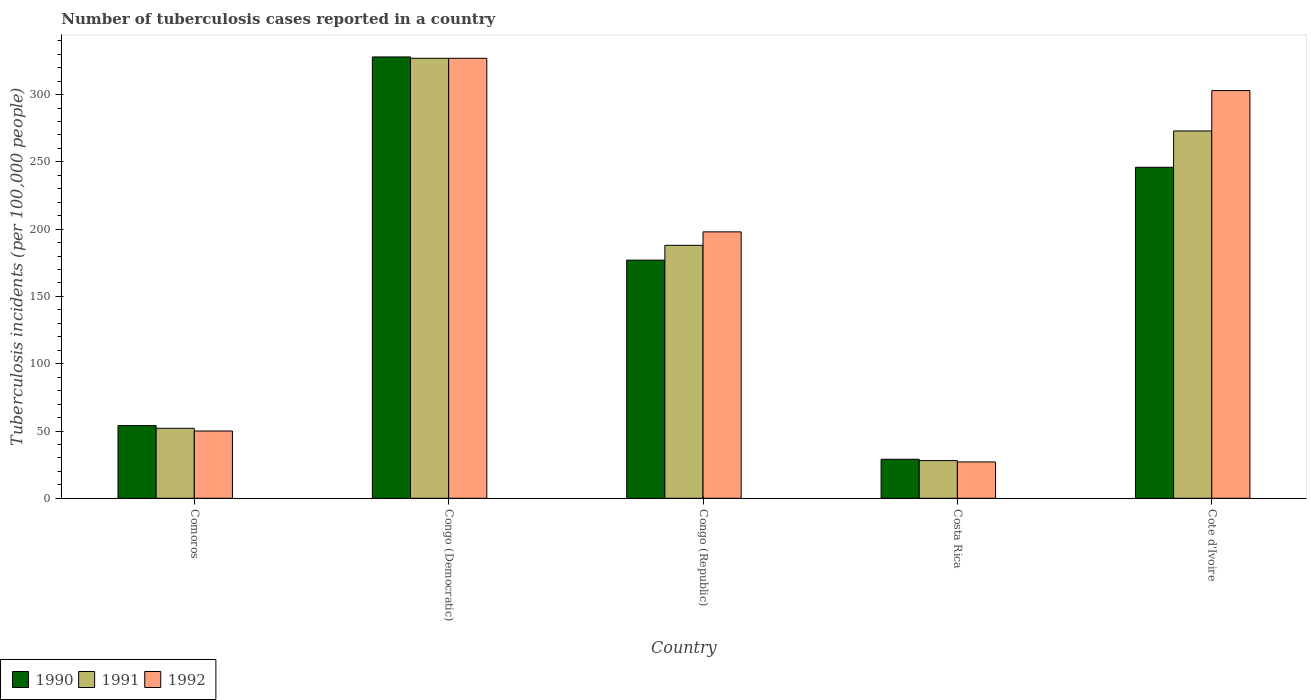In how many cases, is the number of bars for a given country not equal to the number of legend labels?
Make the answer very short. 0. Across all countries, what is the maximum number of tuberculosis cases reported in in 1992?
Offer a terse response. 327. In which country was the number of tuberculosis cases reported in in 1991 maximum?
Offer a terse response. Congo (Democratic). What is the total number of tuberculosis cases reported in in 1992 in the graph?
Provide a succinct answer. 905. What is the difference between the number of tuberculosis cases reported in in 1990 in Comoros and that in Cote d'Ivoire?
Make the answer very short. -192. What is the difference between the number of tuberculosis cases reported in in 1991 in Congo (Democratic) and the number of tuberculosis cases reported in in 1992 in Costa Rica?
Offer a very short reply. 300. What is the average number of tuberculosis cases reported in in 1991 per country?
Offer a terse response. 173.6. What is the difference between the number of tuberculosis cases reported in of/in 1990 and number of tuberculosis cases reported in of/in 1991 in Congo (Democratic)?
Your response must be concise. 1. What is the ratio of the number of tuberculosis cases reported in in 1990 in Congo (Republic) to that in Costa Rica?
Ensure brevity in your answer.  6.1. Is the number of tuberculosis cases reported in in 1990 in Congo (Democratic) less than that in Costa Rica?
Offer a terse response. No. What is the difference between the highest and the second highest number of tuberculosis cases reported in in 1990?
Make the answer very short. 151. What is the difference between the highest and the lowest number of tuberculosis cases reported in in 1990?
Keep it short and to the point. 299. In how many countries, is the number of tuberculosis cases reported in in 1991 greater than the average number of tuberculosis cases reported in in 1991 taken over all countries?
Your answer should be very brief. 3. What does the 2nd bar from the right in Cote d'Ivoire represents?
Provide a short and direct response. 1991. How many bars are there?
Give a very brief answer. 15. Are all the bars in the graph horizontal?
Ensure brevity in your answer.  No. How many countries are there in the graph?
Offer a very short reply. 5. Are the values on the major ticks of Y-axis written in scientific E-notation?
Your answer should be very brief. No. Does the graph contain grids?
Offer a very short reply. No. Where does the legend appear in the graph?
Ensure brevity in your answer.  Bottom left. How are the legend labels stacked?
Offer a very short reply. Horizontal. What is the title of the graph?
Your answer should be very brief. Number of tuberculosis cases reported in a country. Does "2011" appear as one of the legend labels in the graph?
Ensure brevity in your answer.  No. What is the label or title of the X-axis?
Make the answer very short. Country. What is the label or title of the Y-axis?
Your answer should be very brief. Tuberculosis incidents (per 100,0 people). What is the Tuberculosis incidents (per 100,000 people) in 1990 in Comoros?
Provide a short and direct response. 54. What is the Tuberculosis incidents (per 100,000 people) of 1990 in Congo (Democratic)?
Your response must be concise. 328. What is the Tuberculosis incidents (per 100,000 people) in 1991 in Congo (Democratic)?
Keep it short and to the point. 327. What is the Tuberculosis incidents (per 100,000 people) in 1992 in Congo (Democratic)?
Provide a succinct answer. 327. What is the Tuberculosis incidents (per 100,000 people) of 1990 in Congo (Republic)?
Offer a terse response. 177. What is the Tuberculosis incidents (per 100,000 people) in 1991 in Congo (Republic)?
Your answer should be very brief. 188. What is the Tuberculosis incidents (per 100,000 people) of 1992 in Congo (Republic)?
Ensure brevity in your answer.  198. What is the Tuberculosis incidents (per 100,000 people) of 1991 in Costa Rica?
Ensure brevity in your answer.  28. What is the Tuberculosis incidents (per 100,000 people) of 1990 in Cote d'Ivoire?
Your response must be concise. 246. What is the Tuberculosis incidents (per 100,000 people) in 1991 in Cote d'Ivoire?
Keep it short and to the point. 273. What is the Tuberculosis incidents (per 100,000 people) in 1992 in Cote d'Ivoire?
Give a very brief answer. 303. Across all countries, what is the maximum Tuberculosis incidents (per 100,000 people) of 1990?
Ensure brevity in your answer.  328. Across all countries, what is the maximum Tuberculosis incidents (per 100,000 people) in 1991?
Provide a short and direct response. 327. Across all countries, what is the maximum Tuberculosis incidents (per 100,000 people) in 1992?
Your answer should be very brief. 327. Across all countries, what is the minimum Tuberculosis incidents (per 100,000 people) in 1990?
Ensure brevity in your answer.  29. What is the total Tuberculosis incidents (per 100,000 people) of 1990 in the graph?
Provide a succinct answer. 834. What is the total Tuberculosis incidents (per 100,000 people) of 1991 in the graph?
Your answer should be very brief. 868. What is the total Tuberculosis incidents (per 100,000 people) in 1992 in the graph?
Your answer should be compact. 905. What is the difference between the Tuberculosis incidents (per 100,000 people) in 1990 in Comoros and that in Congo (Democratic)?
Your answer should be compact. -274. What is the difference between the Tuberculosis incidents (per 100,000 people) of 1991 in Comoros and that in Congo (Democratic)?
Offer a terse response. -275. What is the difference between the Tuberculosis incidents (per 100,000 people) of 1992 in Comoros and that in Congo (Democratic)?
Your response must be concise. -277. What is the difference between the Tuberculosis incidents (per 100,000 people) of 1990 in Comoros and that in Congo (Republic)?
Give a very brief answer. -123. What is the difference between the Tuberculosis incidents (per 100,000 people) of 1991 in Comoros and that in Congo (Republic)?
Your answer should be very brief. -136. What is the difference between the Tuberculosis incidents (per 100,000 people) of 1992 in Comoros and that in Congo (Republic)?
Provide a short and direct response. -148. What is the difference between the Tuberculosis incidents (per 100,000 people) in 1991 in Comoros and that in Costa Rica?
Give a very brief answer. 24. What is the difference between the Tuberculosis incidents (per 100,000 people) in 1990 in Comoros and that in Cote d'Ivoire?
Provide a short and direct response. -192. What is the difference between the Tuberculosis incidents (per 100,000 people) in 1991 in Comoros and that in Cote d'Ivoire?
Your answer should be compact. -221. What is the difference between the Tuberculosis incidents (per 100,000 people) in 1992 in Comoros and that in Cote d'Ivoire?
Your answer should be very brief. -253. What is the difference between the Tuberculosis incidents (per 100,000 people) in 1990 in Congo (Democratic) and that in Congo (Republic)?
Ensure brevity in your answer.  151. What is the difference between the Tuberculosis incidents (per 100,000 people) of 1991 in Congo (Democratic) and that in Congo (Republic)?
Your answer should be very brief. 139. What is the difference between the Tuberculosis incidents (per 100,000 people) in 1992 in Congo (Democratic) and that in Congo (Republic)?
Ensure brevity in your answer.  129. What is the difference between the Tuberculosis incidents (per 100,000 people) in 1990 in Congo (Democratic) and that in Costa Rica?
Give a very brief answer. 299. What is the difference between the Tuberculosis incidents (per 100,000 people) in 1991 in Congo (Democratic) and that in Costa Rica?
Offer a very short reply. 299. What is the difference between the Tuberculosis incidents (per 100,000 people) of 1992 in Congo (Democratic) and that in Costa Rica?
Make the answer very short. 300. What is the difference between the Tuberculosis incidents (per 100,000 people) of 1990 in Congo (Republic) and that in Costa Rica?
Provide a short and direct response. 148. What is the difference between the Tuberculosis incidents (per 100,000 people) of 1991 in Congo (Republic) and that in Costa Rica?
Provide a succinct answer. 160. What is the difference between the Tuberculosis incidents (per 100,000 people) in 1992 in Congo (Republic) and that in Costa Rica?
Give a very brief answer. 171. What is the difference between the Tuberculosis incidents (per 100,000 people) of 1990 in Congo (Republic) and that in Cote d'Ivoire?
Your response must be concise. -69. What is the difference between the Tuberculosis incidents (per 100,000 people) in 1991 in Congo (Republic) and that in Cote d'Ivoire?
Provide a short and direct response. -85. What is the difference between the Tuberculosis incidents (per 100,000 people) in 1992 in Congo (Republic) and that in Cote d'Ivoire?
Make the answer very short. -105. What is the difference between the Tuberculosis incidents (per 100,000 people) in 1990 in Costa Rica and that in Cote d'Ivoire?
Your answer should be very brief. -217. What is the difference between the Tuberculosis incidents (per 100,000 people) in 1991 in Costa Rica and that in Cote d'Ivoire?
Make the answer very short. -245. What is the difference between the Tuberculosis incidents (per 100,000 people) of 1992 in Costa Rica and that in Cote d'Ivoire?
Your answer should be compact. -276. What is the difference between the Tuberculosis incidents (per 100,000 people) in 1990 in Comoros and the Tuberculosis incidents (per 100,000 people) in 1991 in Congo (Democratic)?
Ensure brevity in your answer.  -273. What is the difference between the Tuberculosis incidents (per 100,000 people) in 1990 in Comoros and the Tuberculosis incidents (per 100,000 people) in 1992 in Congo (Democratic)?
Keep it short and to the point. -273. What is the difference between the Tuberculosis incidents (per 100,000 people) of 1991 in Comoros and the Tuberculosis incidents (per 100,000 people) of 1992 in Congo (Democratic)?
Your response must be concise. -275. What is the difference between the Tuberculosis incidents (per 100,000 people) in 1990 in Comoros and the Tuberculosis incidents (per 100,000 people) in 1991 in Congo (Republic)?
Keep it short and to the point. -134. What is the difference between the Tuberculosis incidents (per 100,000 people) of 1990 in Comoros and the Tuberculosis incidents (per 100,000 people) of 1992 in Congo (Republic)?
Your response must be concise. -144. What is the difference between the Tuberculosis incidents (per 100,000 people) of 1991 in Comoros and the Tuberculosis incidents (per 100,000 people) of 1992 in Congo (Republic)?
Provide a short and direct response. -146. What is the difference between the Tuberculosis incidents (per 100,000 people) of 1990 in Comoros and the Tuberculosis incidents (per 100,000 people) of 1991 in Cote d'Ivoire?
Your answer should be very brief. -219. What is the difference between the Tuberculosis incidents (per 100,000 people) in 1990 in Comoros and the Tuberculosis incidents (per 100,000 people) in 1992 in Cote d'Ivoire?
Provide a succinct answer. -249. What is the difference between the Tuberculosis incidents (per 100,000 people) in 1991 in Comoros and the Tuberculosis incidents (per 100,000 people) in 1992 in Cote d'Ivoire?
Make the answer very short. -251. What is the difference between the Tuberculosis incidents (per 100,000 people) in 1990 in Congo (Democratic) and the Tuberculosis incidents (per 100,000 people) in 1991 in Congo (Republic)?
Provide a succinct answer. 140. What is the difference between the Tuberculosis incidents (per 100,000 people) of 1990 in Congo (Democratic) and the Tuberculosis incidents (per 100,000 people) of 1992 in Congo (Republic)?
Give a very brief answer. 130. What is the difference between the Tuberculosis incidents (per 100,000 people) of 1991 in Congo (Democratic) and the Tuberculosis incidents (per 100,000 people) of 1992 in Congo (Republic)?
Your answer should be compact. 129. What is the difference between the Tuberculosis incidents (per 100,000 people) in 1990 in Congo (Democratic) and the Tuberculosis incidents (per 100,000 people) in 1991 in Costa Rica?
Offer a terse response. 300. What is the difference between the Tuberculosis incidents (per 100,000 people) in 1990 in Congo (Democratic) and the Tuberculosis incidents (per 100,000 people) in 1992 in Costa Rica?
Your answer should be compact. 301. What is the difference between the Tuberculosis incidents (per 100,000 people) of 1991 in Congo (Democratic) and the Tuberculosis incidents (per 100,000 people) of 1992 in Costa Rica?
Provide a short and direct response. 300. What is the difference between the Tuberculosis incidents (per 100,000 people) of 1990 in Congo (Democratic) and the Tuberculosis incidents (per 100,000 people) of 1992 in Cote d'Ivoire?
Your answer should be compact. 25. What is the difference between the Tuberculosis incidents (per 100,000 people) in 1991 in Congo (Democratic) and the Tuberculosis incidents (per 100,000 people) in 1992 in Cote d'Ivoire?
Ensure brevity in your answer.  24. What is the difference between the Tuberculosis incidents (per 100,000 people) in 1990 in Congo (Republic) and the Tuberculosis incidents (per 100,000 people) in 1991 in Costa Rica?
Keep it short and to the point. 149. What is the difference between the Tuberculosis incidents (per 100,000 people) in 1990 in Congo (Republic) and the Tuberculosis incidents (per 100,000 people) in 1992 in Costa Rica?
Ensure brevity in your answer.  150. What is the difference between the Tuberculosis incidents (per 100,000 people) in 1991 in Congo (Republic) and the Tuberculosis incidents (per 100,000 people) in 1992 in Costa Rica?
Provide a short and direct response. 161. What is the difference between the Tuberculosis incidents (per 100,000 people) in 1990 in Congo (Republic) and the Tuberculosis incidents (per 100,000 people) in 1991 in Cote d'Ivoire?
Offer a very short reply. -96. What is the difference between the Tuberculosis incidents (per 100,000 people) of 1990 in Congo (Republic) and the Tuberculosis incidents (per 100,000 people) of 1992 in Cote d'Ivoire?
Provide a short and direct response. -126. What is the difference between the Tuberculosis incidents (per 100,000 people) of 1991 in Congo (Republic) and the Tuberculosis incidents (per 100,000 people) of 1992 in Cote d'Ivoire?
Keep it short and to the point. -115. What is the difference between the Tuberculosis incidents (per 100,000 people) in 1990 in Costa Rica and the Tuberculosis incidents (per 100,000 people) in 1991 in Cote d'Ivoire?
Ensure brevity in your answer.  -244. What is the difference between the Tuberculosis incidents (per 100,000 people) of 1990 in Costa Rica and the Tuberculosis incidents (per 100,000 people) of 1992 in Cote d'Ivoire?
Provide a succinct answer. -274. What is the difference between the Tuberculosis incidents (per 100,000 people) in 1991 in Costa Rica and the Tuberculosis incidents (per 100,000 people) in 1992 in Cote d'Ivoire?
Ensure brevity in your answer.  -275. What is the average Tuberculosis incidents (per 100,000 people) of 1990 per country?
Keep it short and to the point. 166.8. What is the average Tuberculosis incidents (per 100,000 people) in 1991 per country?
Provide a short and direct response. 173.6. What is the average Tuberculosis incidents (per 100,000 people) in 1992 per country?
Your response must be concise. 181. What is the difference between the Tuberculosis incidents (per 100,000 people) of 1990 and Tuberculosis incidents (per 100,000 people) of 1992 in Comoros?
Keep it short and to the point. 4. What is the difference between the Tuberculosis incidents (per 100,000 people) in 1990 and Tuberculosis incidents (per 100,000 people) in 1992 in Congo (Democratic)?
Offer a very short reply. 1. What is the difference between the Tuberculosis incidents (per 100,000 people) of 1990 and Tuberculosis incidents (per 100,000 people) of 1991 in Congo (Republic)?
Your answer should be very brief. -11. What is the difference between the Tuberculosis incidents (per 100,000 people) in 1990 and Tuberculosis incidents (per 100,000 people) in 1992 in Congo (Republic)?
Offer a terse response. -21. What is the difference between the Tuberculosis incidents (per 100,000 people) in 1991 and Tuberculosis incidents (per 100,000 people) in 1992 in Congo (Republic)?
Offer a very short reply. -10. What is the difference between the Tuberculosis incidents (per 100,000 people) of 1990 and Tuberculosis incidents (per 100,000 people) of 1991 in Costa Rica?
Your answer should be very brief. 1. What is the difference between the Tuberculosis incidents (per 100,000 people) of 1990 and Tuberculosis incidents (per 100,000 people) of 1992 in Costa Rica?
Ensure brevity in your answer.  2. What is the difference between the Tuberculosis incidents (per 100,000 people) in 1990 and Tuberculosis incidents (per 100,000 people) in 1992 in Cote d'Ivoire?
Offer a very short reply. -57. What is the difference between the Tuberculosis incidents (per 100,000 people) of 1991 and Tuberculosis incidents (per 100,000 people) of 1992 in Cote d'Ivoire?
Provide a short and direct response. -30. What is the ratio of the Tuberculosis incidents (per 100,000 people) of 1990 in Comoros to that in Congo (Democratic)?
Ensure brevity in your answer.  0.16. What is the ratio of the Tuberculosis incidents (per 100,000 people) in 1991 in Comoros to that in Congo (Democratic)?
Keep it short and to the point. 0.16. What is the ratio of the Tuberculosis incidents (per 100,000 people) of 1992 in Comoros to that in Congo (Democratic)?
Your answer should be very brief. 0.15. What is the ratio of the Tuberculosis incidents (per 100,000 people) of 1990 in Comoros to that in Congo (Republic)?
Give a very brief answer. 0.31. What is the ratio of the Tuberculosis incidents (per 100,000 people) of 1991 in Comoros to that in Congo (Republic)?
Provide a succinct answer. 0.28. What is the ratio of the Tuberculosis incidents (per 100,000 people) of 1992 in Comoros to that in Congo (Republic)?
Your answer should be very brief. 0.25. What is the ratio of the Tuberculosis incidents (per 100,000 people) of 1990 in Comoros to that in Costa Rica?
Your answer should be very brief. 1.86. What is the ratio of the Tuberculosis incidents (per 100,000 people) of 1991 in Comoros to that in Costa Rica?
Give a very brief answer. 1.86. What is the ratio of the Tuberculosis incidents (per 100,000 people) in 1992 in Comoros to that in Costa Rica?
Your answer should be very brief. 1.85. What is the ratio of the Tuberculosis incidents (per 100,000 people) of 1990 in Comoros to that in Cote d'Ivoire?
Give a very brief answer. 0.22. What is the ratio of the Tuberculosis incidents (per 100,000 people) of 1991 in Comoros to that in Cote d'Ivoire?
Offer a very short reply. 0.19. What is the ratio of the Tuberculosis incidents (per 100,000 people) in 1992 in Comoros to that in Cote d'Ivoire?
Give a very brief answer. 0.17. What is the ratio of the Tuberculosis incidents (per 100,000 people) of 1990 in Congo (Democratic) to that in Congo (Republic)?
Offer a terse response. 1.85. What is the ratio of the Tuberculosis incidents (per 100,000 people) in 1991 in Congo (Democratic) to that in Congo (Republic)?
Offer a very short reply. 1.74. What is the ratio of the Tuberculosis incidents (per 100,000 people) in 1992 in Congo (Democratic) to that in Congo (Republic)?
Keep it short and to the point. 1.65. What is the ratio of the Tuberculosis incidents (per 100,000 people) of 1990 in Congo (Democratic) to that in Costa Rica?
Give a very brief answer. 11.31. What is the ratio of the Tuberculosis incidents (per 100,000 people) in 1991 in Congo (Democratic) to that in Costa Rica?
Your answer should be very brief. 11.68. What is the ratio of the Tuberculosis incidents (per 100,000 people) of 1992 in Congo (Democratic) to that in Costa Rica?
Keep it short and to the point. 12.11. What is the ratio of the Tuberculosis incidents (per 100,000 people) in 1990 in Congo (Democratic) to that in Cote d'Ivoire?
Your answer should be very brief. 1.33. What is the ratio of the Tuberculosis incidents (per 100,000 people) of 1991 in Congo (Democratic) to that in Cote d'Ivoire?
Provide a short and direct response. 1.2. What is the ratio of the Tuberculosis incidents (per 100,000 people) in 1992 in Congo (Democratic) to that in Cote d'Ivoire?
Offer a terse response. 1.08. What is the ratio of the Tuberculosis incidents (per 100,000 people) in 1990 in Congo (Republic) to that in Costa Rica?
Provide a short and direct response. 6.1. What is the ratio of the Tuberculosis incidents (per 100,000 people) in 1991 in Congo (Republic) to that in Costa Rica?
Your answer should be compact. 6.71. What is the ratio of the Tuberculosis incidents (per 100,000 people) of 1992 in Congo (Republic) to that in Costa Rica?
Your answer should be very brief. 7.33. What is the ratio of the Tuberculosis incidents (per 100,000 people) in 1990 in Congo (Republic) to that in Cote d'Ivoire?
Make the answer very short. 0.72. What is the ratio of the Tuberculosis incidents (per 100,000 people) in 1991 in Congo (Republic) to that in Cote d'Ivoire?
Provide a succinct answer. 0.69. What is the ratio of the Tuberculosis incidents (per 100,000 people) of 1992 in Congo (Republic) to that in Cote d'Ivoire?
Your answer should be compact. 0.65. What is the ratio of the Tuberculosis incidents (per 100,000 people) in 1990 in Costa Rica to that in Cote d'Ivoire?
Provide a succinct answer. 0.12. What is the ratio of the Tuberculosis incidents (per 100,000 people) in 1991 in Costa Rica to that in Cote d'Ivoire?
Ensure brevity in your answer.  0.1. What is the ratio of the Tuberculosis incidents (per 100,000 people) in 1992 in Costa Rica to that in Cote d'Ivoire?
Offer a very short reply. 0.09. What is the difference between the highest and the second highest Tuberculosis incidents (per 100,000 people) of 1991?
Give a very brief answer. 54. What is the difference between the highest and the second highest Tuberculosis incidents (per 100,000 people) of 1992?
Offer a terse response. 24. What is the difference between the highest and the lowest Tuberculosis incidents (per 100,000 people) in 1990?
Ensure brevity in your answer.  299. What is the difference between the highest and the lowest Tuberculosis incidents (per 100,000 people) of 1991?
Keep it short and to the point. 299. What is the difference between the highest and the lowest Tuberculosis incidents (per 100,000 people) in 1992?
Offer a terse response. 300. 